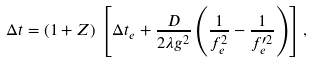Convert formula to latex. <formula><loc_0><loc_0><loc_500><loc_500>\Delta t = ( 1 + Z ) \, \left [ \Delta t _ { e } + \frac { D } { 2 \lambda g ^ { 2 } } \left ( \frac { 1 } { f _ { e } ^ { 2 } } - \frac { 1 } { f _ { e } ^ { \prime 2 } } \right ) \right ] ,</formula> 